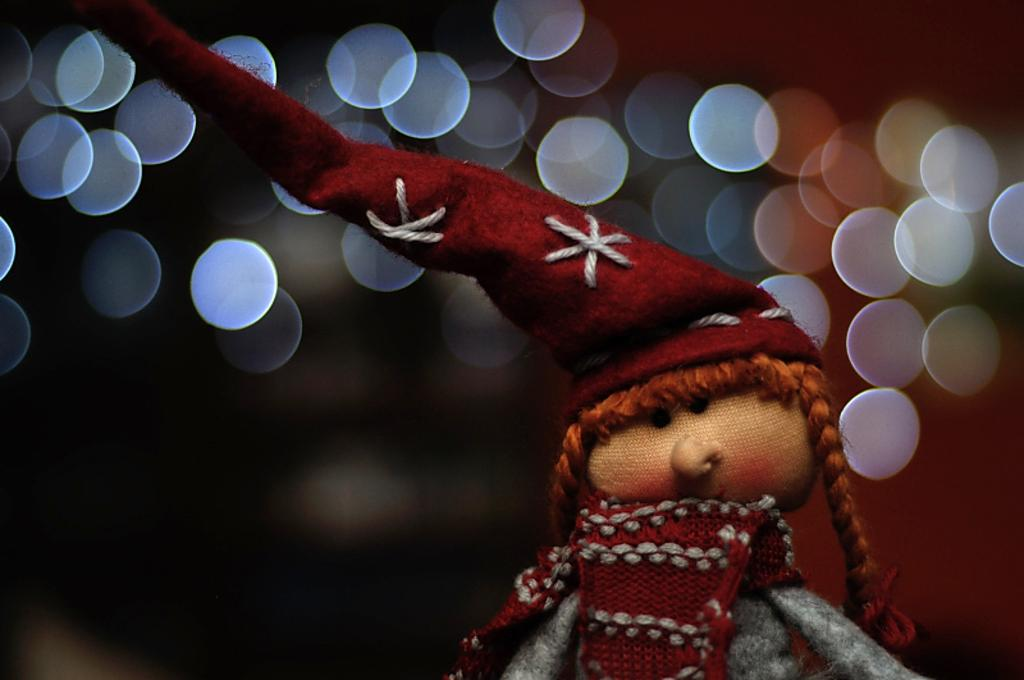What is the main subject of the picture? The main subject of the picture is a doll. What is the doll wearing on its head? The doll is wearing a red color cap in the picture. What can be seen in the background of the picture? There are lights visible in the background of the picture. How many pages are visible in the picture? There are no pages present in the picture; it features a doll and a red color cap. What type of division is visible in the picture? There is no division present in the picture; it features a doll and a red color cap. 